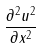Convert formula to latex. <formula><loc_0><loc_0><loc_500><loc_500>\frac { \partial ^ { 2 } u ^ { 2 } } { \partial x ^ { 2 } }</formula> 